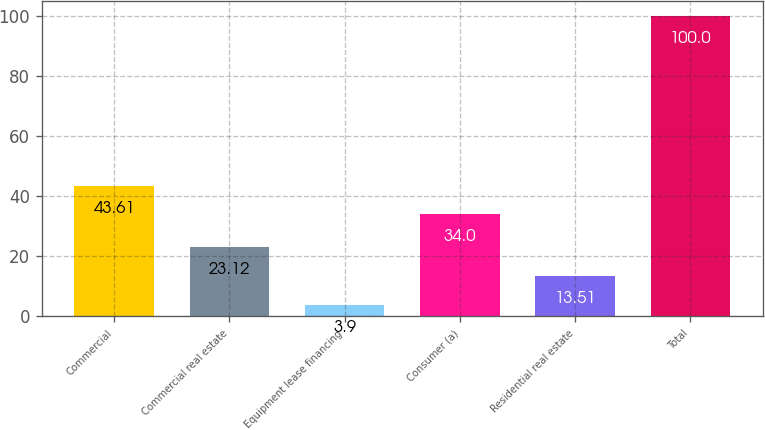Convert chart to OTSL. <chart><loc_0><loc_0><loc_500><loc_500><bar_chart><fcel>Commercial<fcel>Commercial real estate<fcel>Equipment lease financing<fcel>Consumer (a)<fcel>Residential real estate<fcel>Total<nl><fcel>43.61<fcel>23.12<fcel>3.9<fcel>34<fcel>13.51<fcel>100<nl></chart> 